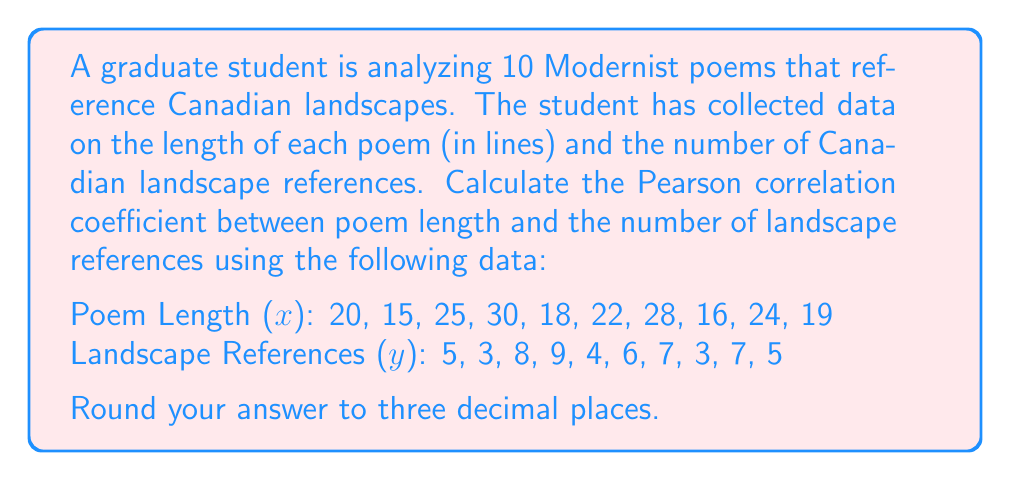Give your solution to this math problem. To calculate the Pearson correlation coefficient (r), we'll use the formula:

$$ r = \frac{n\sum xy - \sum x \sum y}{\sqrt{[n\sum x^2 - (\sum x)^2][n\sum y^2 - (\sum y)^2]}} $$

Step 1: Calculate the sums and squared sums:
$\sum x = 217$, $\sum y = 57$, $\sum xy = 1,323$
$\sum x^2 = 4,963$, $\sum y^2 = 355$

Step 2: Calculate $n\sum xy$ and $\sum x \sum y$:
$n\sum xy = 10 \times 1,323 = 13,230$
$\sum x \sum y = 217 \times 57 = 12,369$

Step 3: Calculate the numerator:
$n\sum xy - \sum x \sum y = 13,230 - 12,369 = 861$

Step 4: Calculate the parts of the denominator:
$n\sum x^2 - (\sum x)^2 = 10 \times 4,963 - 217^2 = 49,630 - 47,089 = 2,541$
$n\sum y^2 - (\sum y)^2 = 10 \times 355 - 57^2 = 3,550 - 3,249 = 301$

Step 5: Calculate the full denominator:
$\sqrt{[n\sum x^2 - (\sum x)^2][n\sum y^2 - (\sum y)^2]} = \sqrt{2,541 \times 301} = \sqrt{764,841} \approx 874.553$

Step 6: Divide the numerator by the denominator:
$r = \frac{861}{874.553} \approx 0.984$

Step 7: Round to three decimal places:
$r \approx 0.984$
Answer: 0.984 